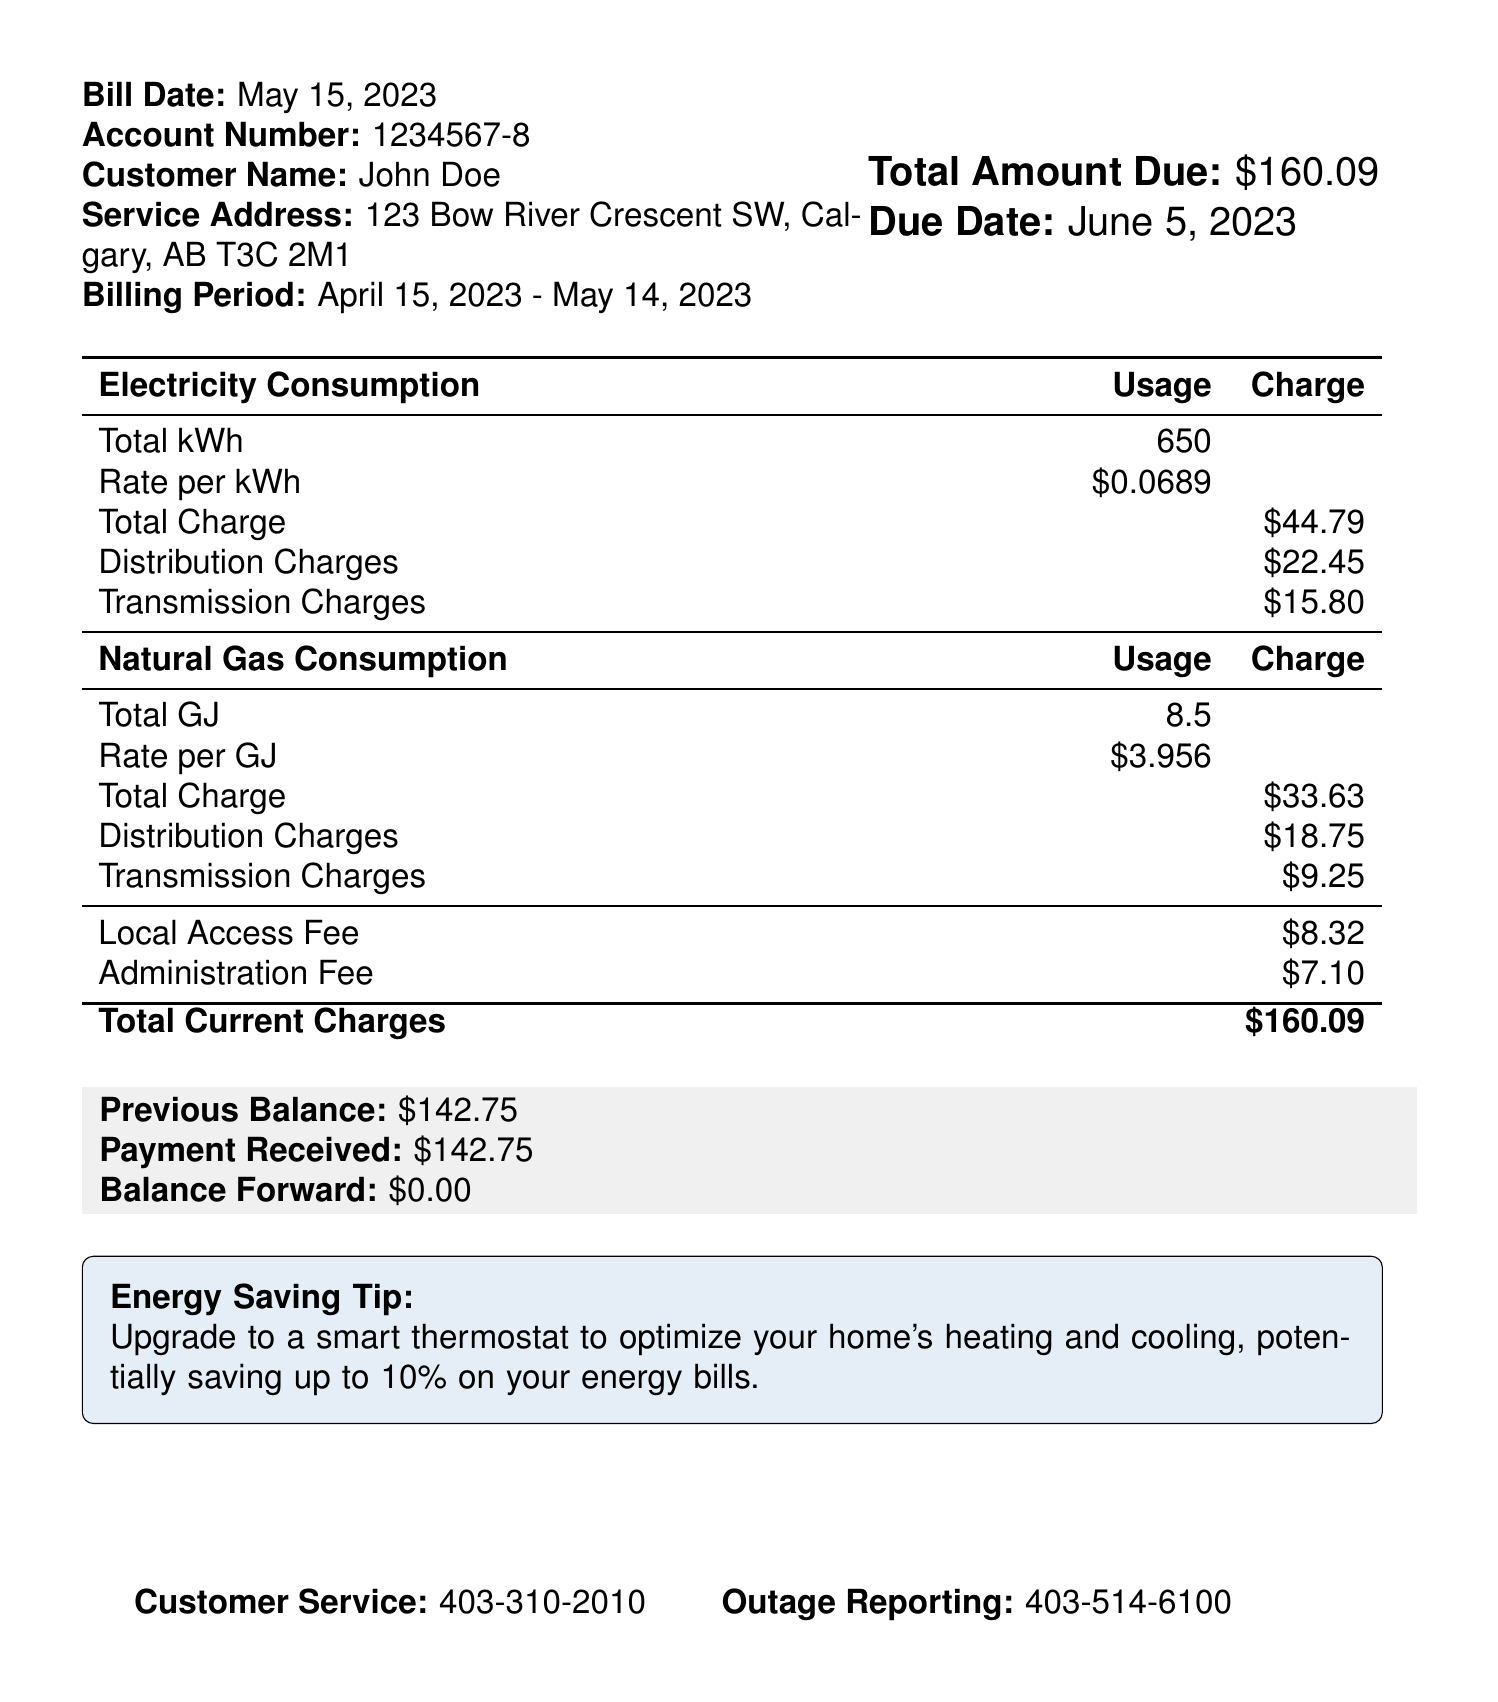what is the total amount due? The total amount due is stated clearly in the document as the sum of current charges.
Answer: $160.09 what is the billing period? The billing period is specified in the document, detailing the start and end dates of the bill.
Answer: April 15, 2023 - May 14, 2023 what is the usage of electricity in kilowatt-hours? The document provides the total electricity consumption in kilowatt-hours as part of the electricity section.
Answer: 650 what is the rate per GJ for natural gas? The rate for natural gas is listed in the document under natural gas consumption.
Answer: $3.956 what is the due date for the payment? The due date for the payment is provided right next to the total amount due.
Answer: June 5, 2023 what is the total charge for electricity? The total charge for electricity is calculated and presented in the table of electricity consumption.
Answer: $44.79 how much is the distribution charge for natural gas? The document specifies the distribution charge for natural gas under the natural gas section.
Answer: $18.75 what should I do if I have a power outage? The document includes a dedicated contact number for reporting outages, indicating what actions to take.
Answer: 403-514-6100 what is one energy saving tip mentioned in the document? The document provides a tip aimed at efficient energy use, which is highlighted in a special box.
Answer: Upgrade to a smart thermostat 